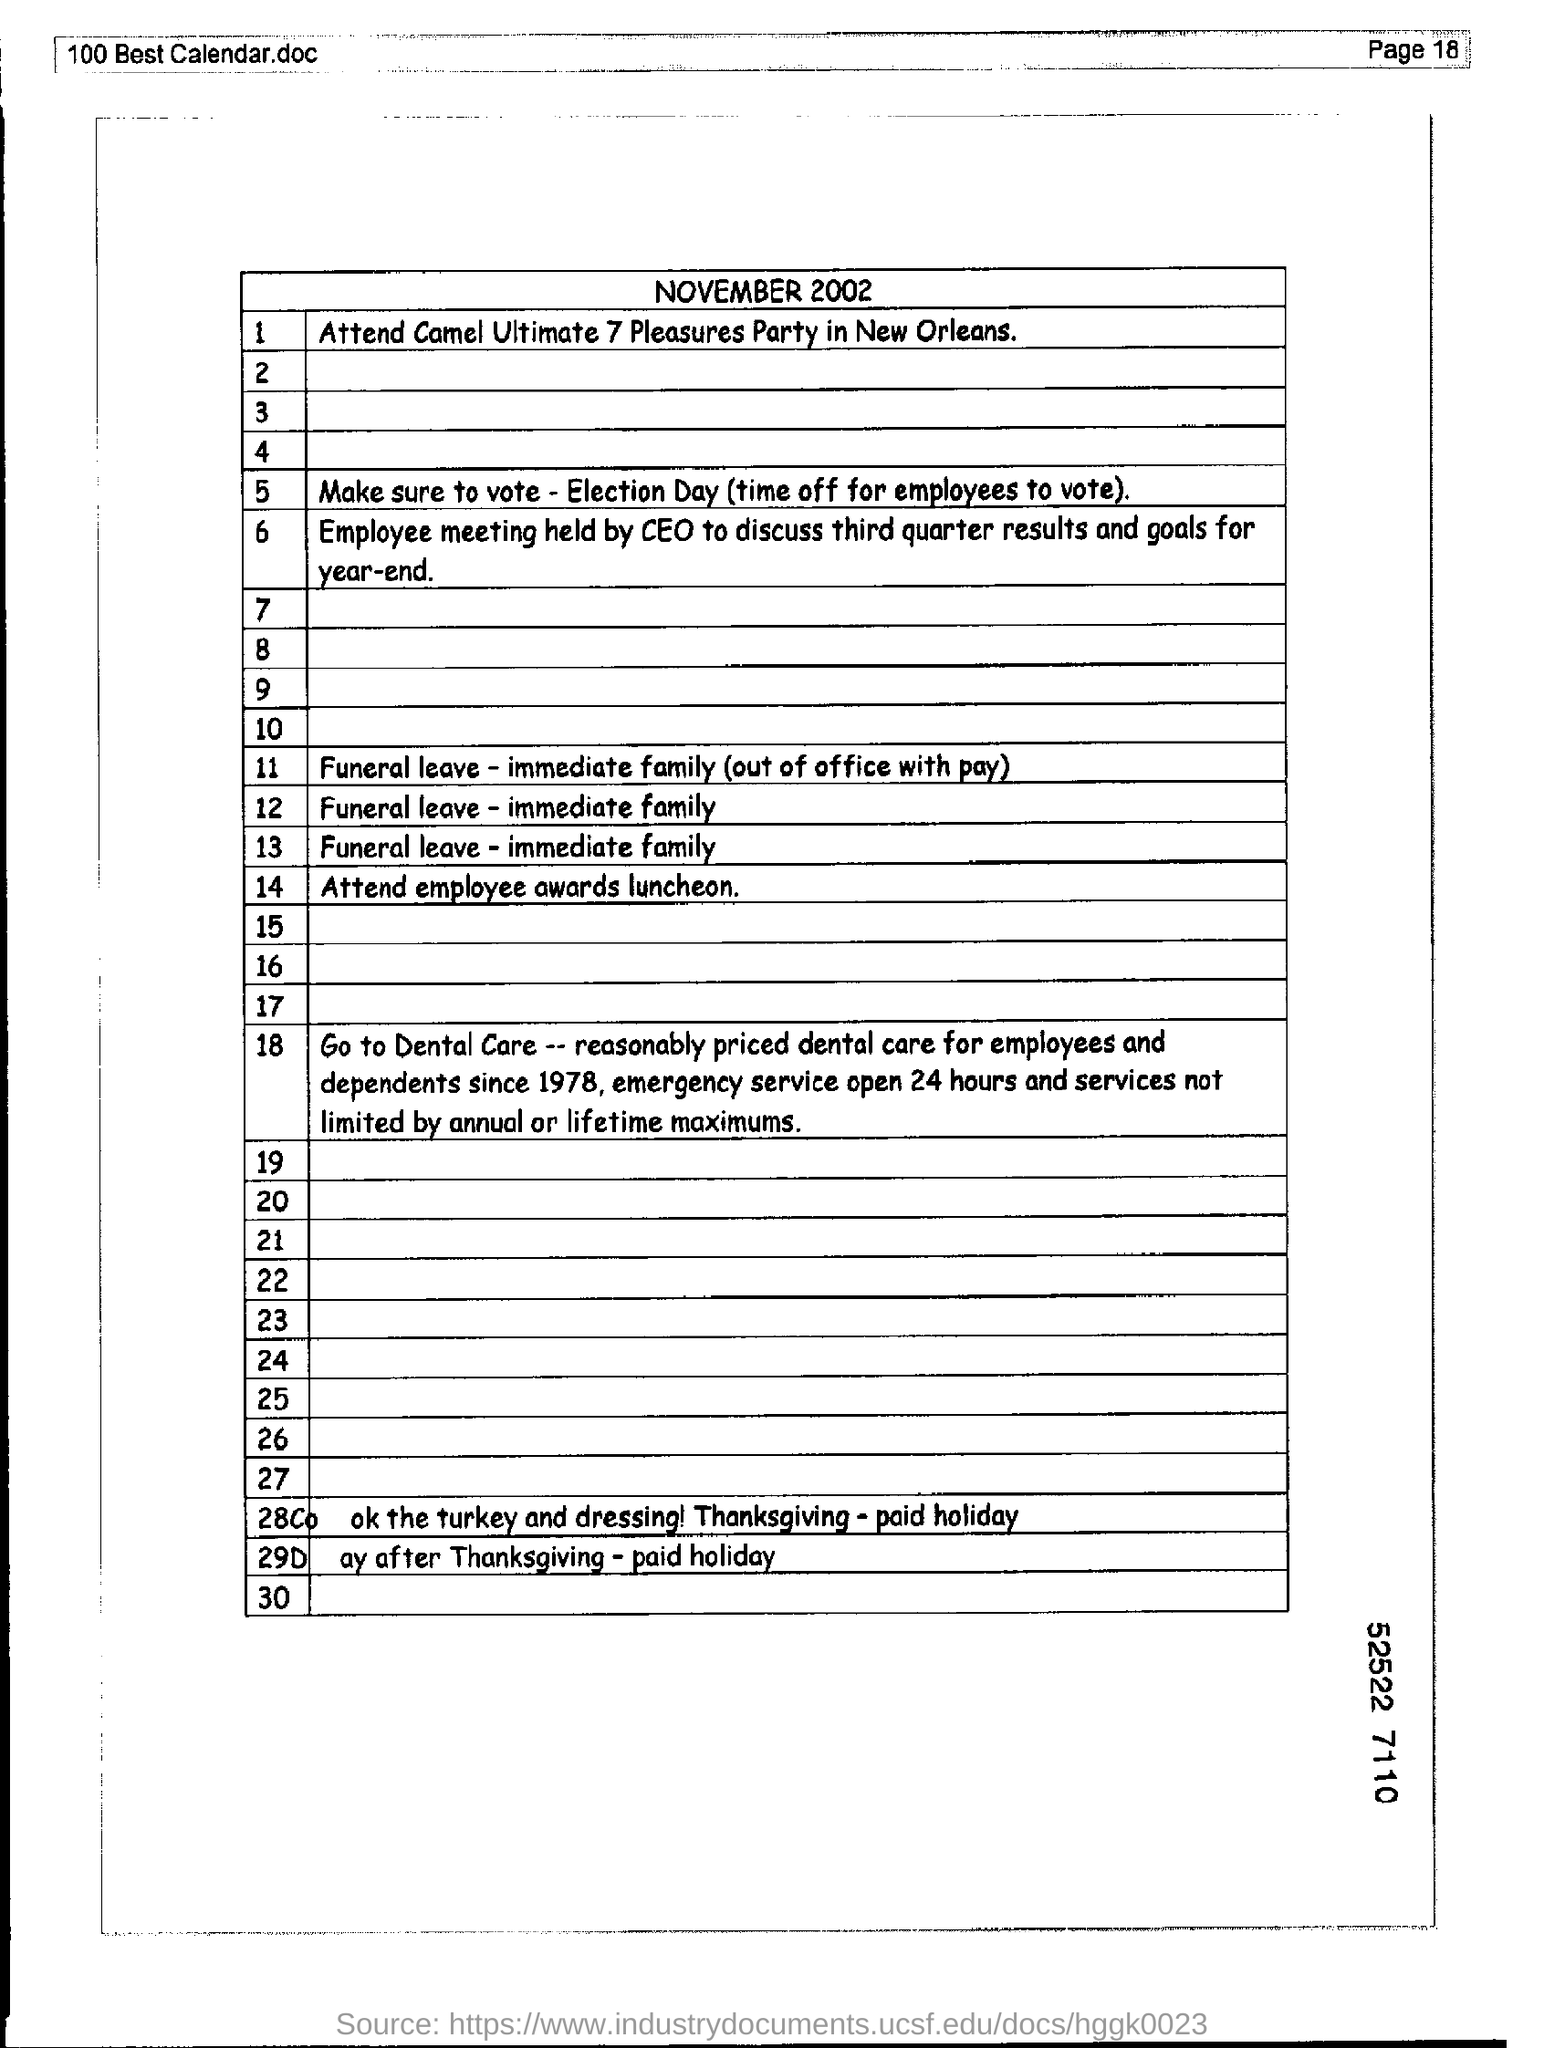Mention a couple of crucial points in this snapshot. The document mentions November 2002. It is imperative to mention the page number at the top right corner of the page, specifically page 18. 